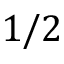Convert formula to latex. <formula><loc_0><loc_0><loc_500><loc_500>1 / 2</formula> 